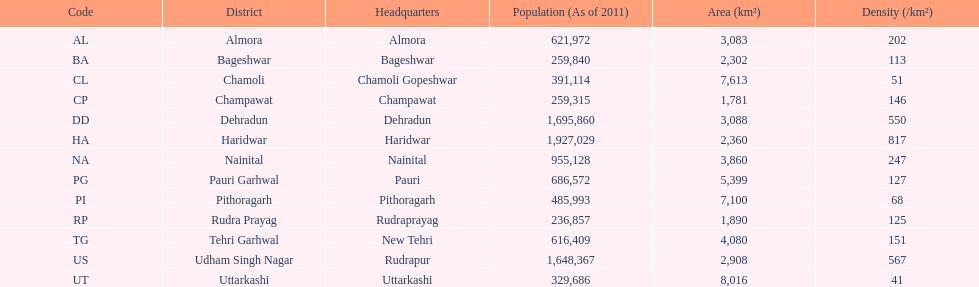Which main office has the identical district designation but with a density of 202? Almora. 